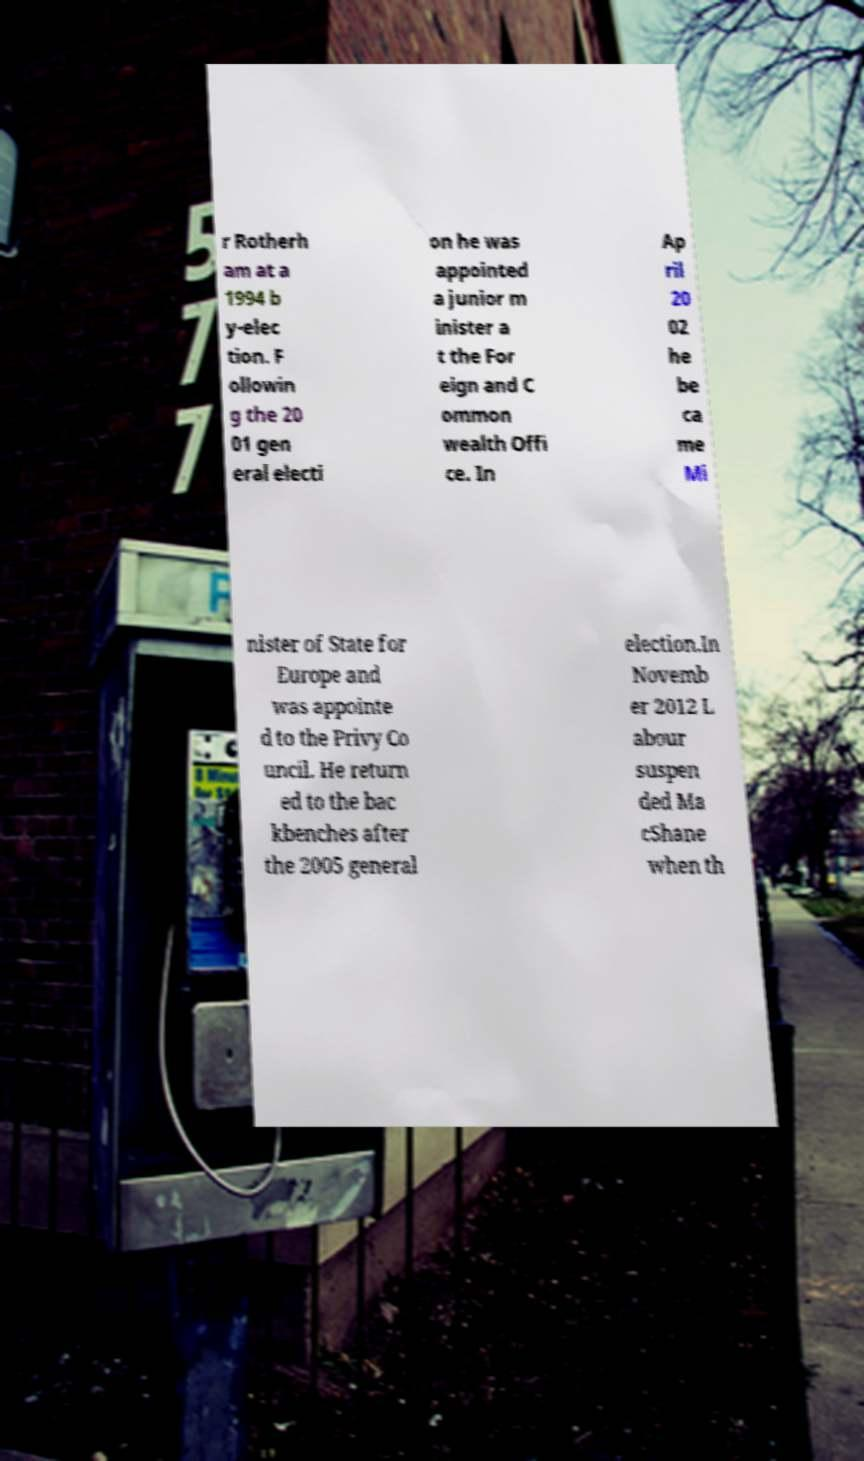Can you read and provide the text displayed in the image?This photo seems to have some interesting text. Can you extract and type it out for me? r Rotherh am at a 1994 b y-elec tion. F ollowin g the 20 01 gen eral electi on he was appointed a junior m inister a t the For eign and C ommon wealth Offi ce. In Ap ril 20 02 he be ca me Mi nister of State for Europe and was appointe d to the Privy Co uncil. He return ed to the bac kbenches after the 2005 general election.In Novemb er 2012 L abour suspen ded Ma cShane when th 